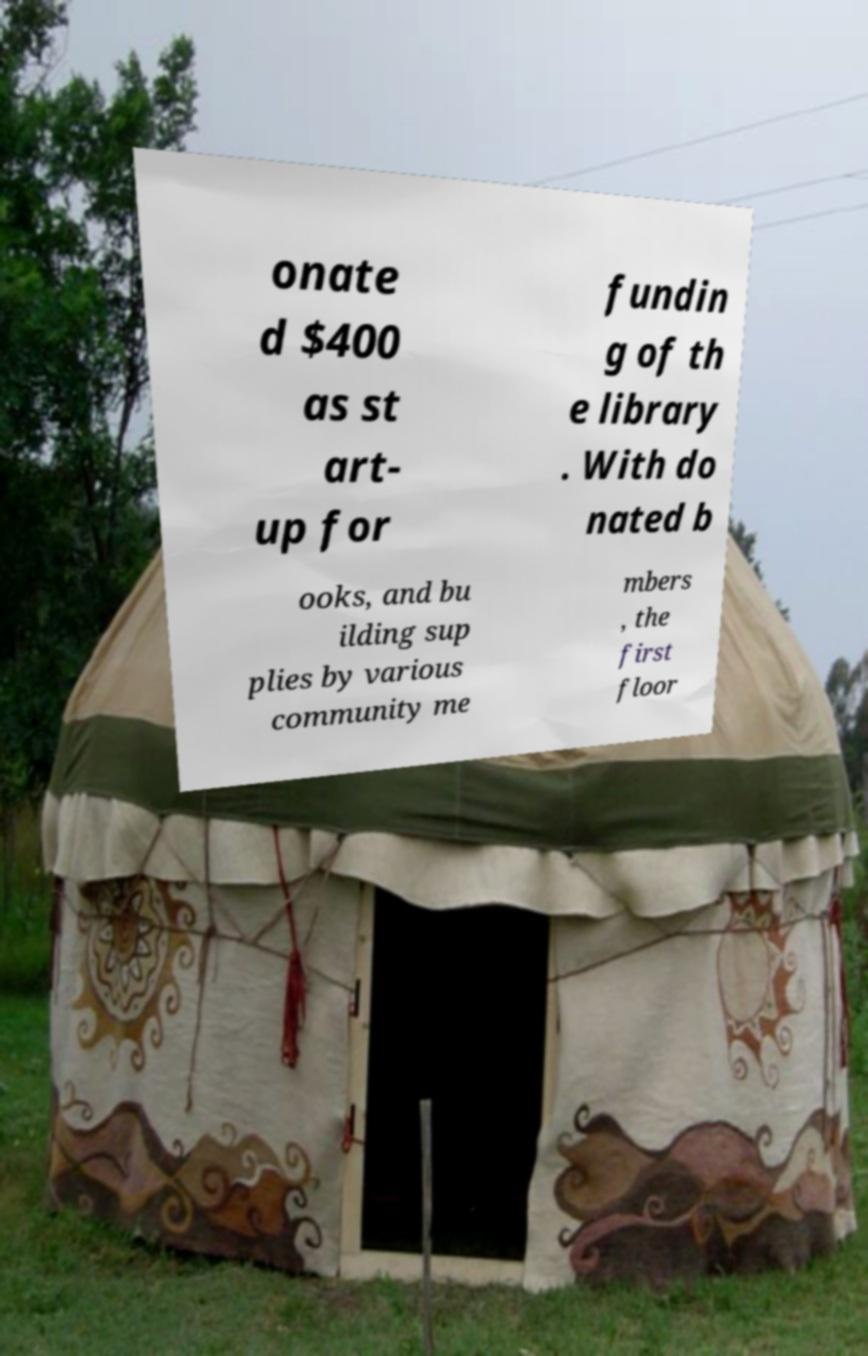Can you read and provide the text displayed in the image?This photo seems to have some interesting text. Can you extract and type it out for me? onate d $400 as st art- up for fundin g of th e library . With do nated b ooks, and bu ilding sup plies by various community me mbers , the first floor 